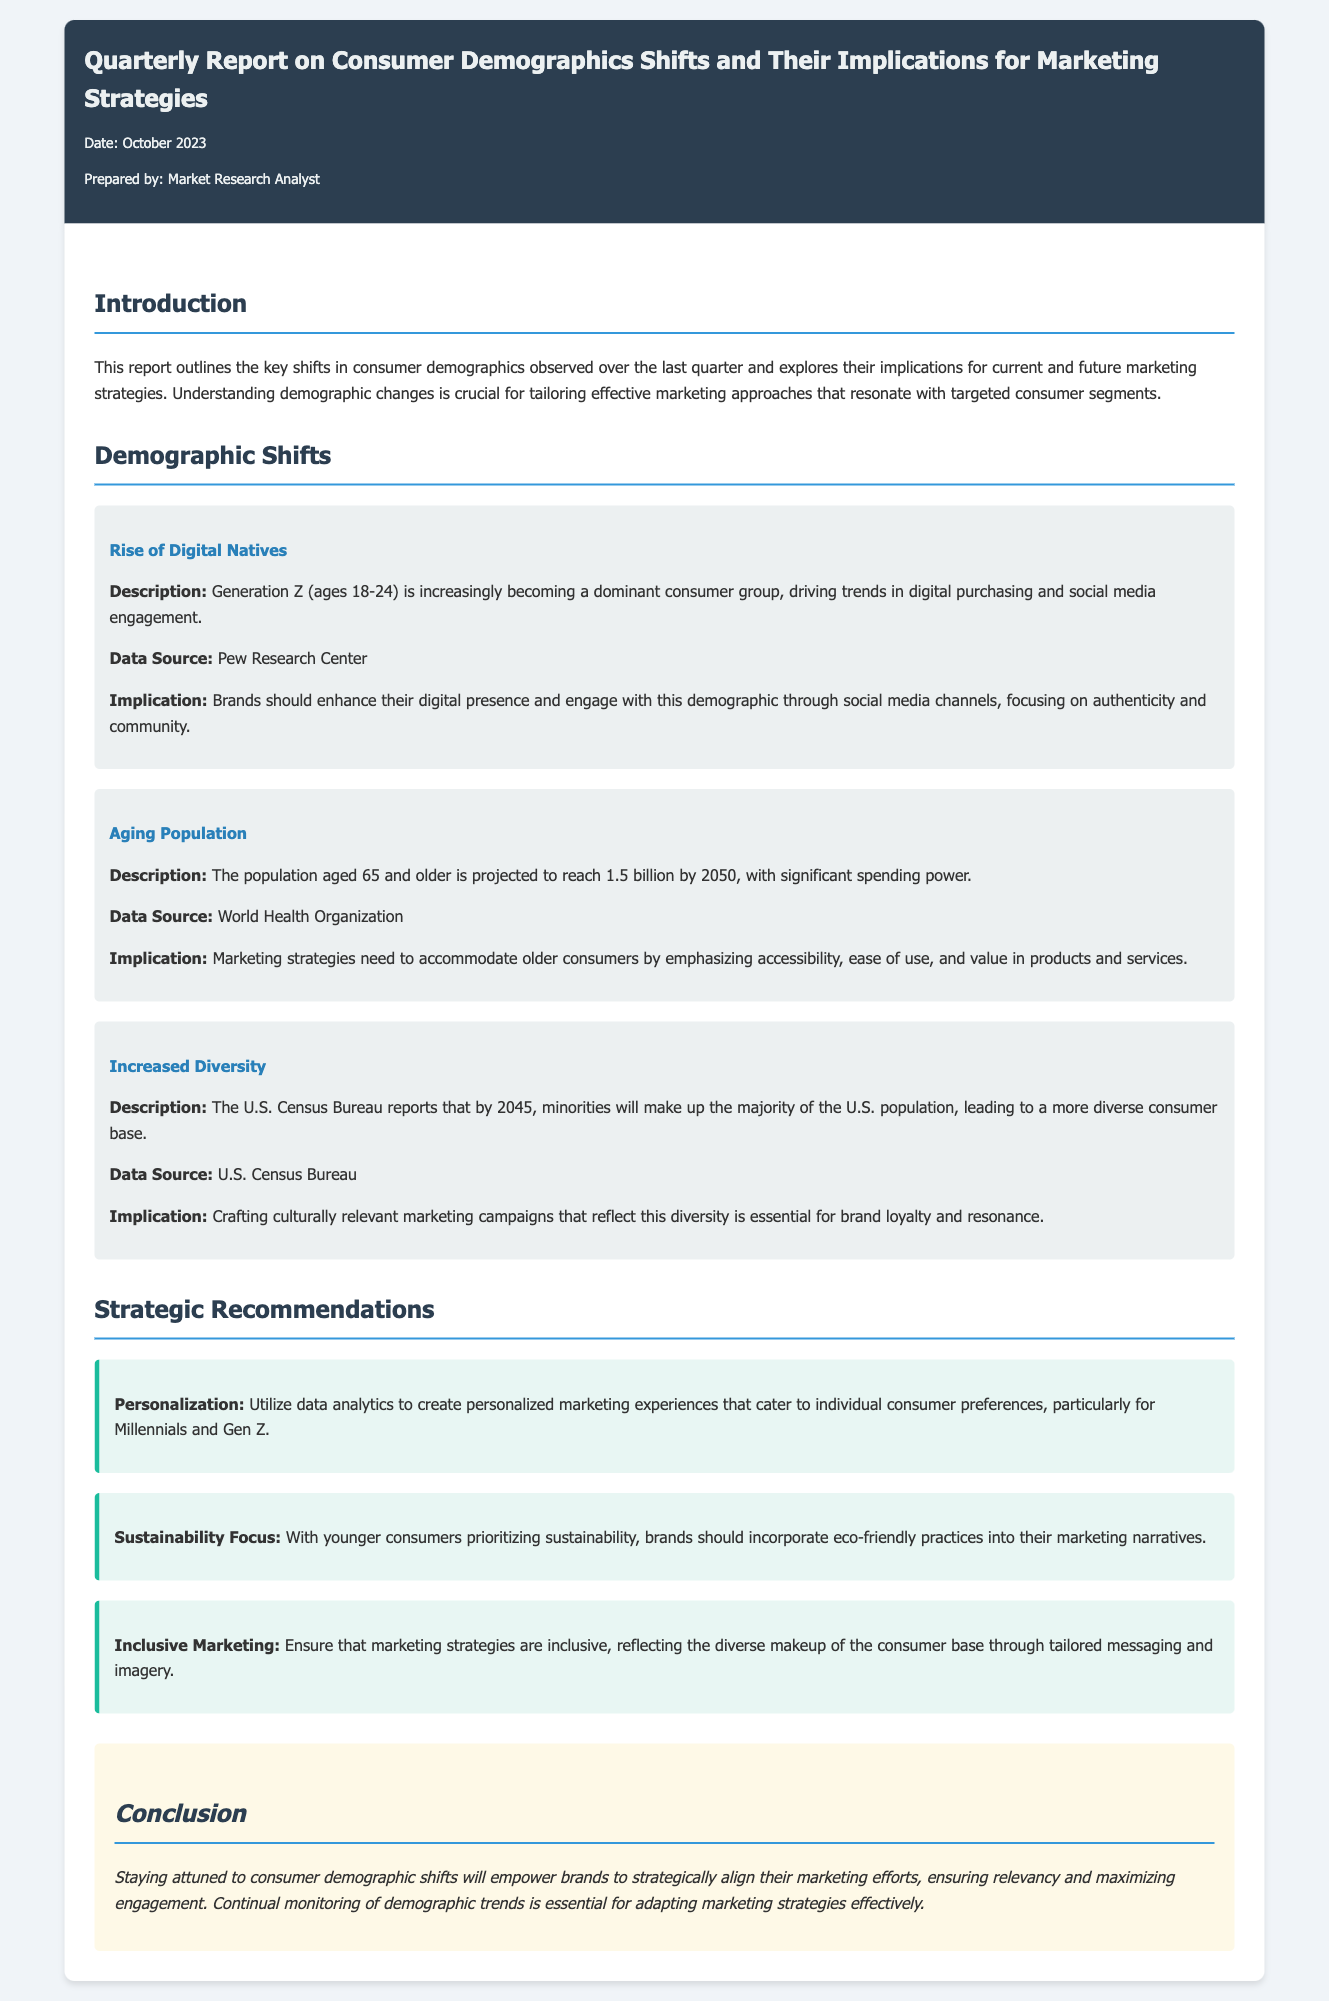What is the title of the report? The title of the report is provided in the header section of the memo.
Answer: Quarterly Report on Consumer Demographics Shifts and Their Implications for Marketing Strategies What is the date of preparation for the report? The date is mentioned in the memo meta section.
Answer: October 2023 Which demographic group is identified as the rising consumer group? The report specifies a particular demographic group driving trends.
Answer: Generation Z What is the projected population of 65 and older by 2050? The projected number is highlighted in the demographic shifts section.
Answer: 1.5 billion What is a recommended focus for brands targeting younger consumers? The recommendations for marketing strategies are detailed in the memo's strategic recommendations section.
Answer: Sustainability Focus What specific approach is suggested for engaging with diverse consumers? The document offers guidance on how to appeal to a diverse consumer base.
Answer: Inclusive Marketing What data source is cited for the increased diversity demographic shift? The report references a specific organization for its demographic data.
Answer: U.S. Census Bureau What is the implication of the rise of digital natives? The implications section provides insight into marketing strategies for this demographic.
Answer: Enhance digital presence What is emphasized for marketing strategies targeting older consumers? The relevant demographic shifts provide guidance on engaging this age group.
Answer: Accessibility and ease of use 